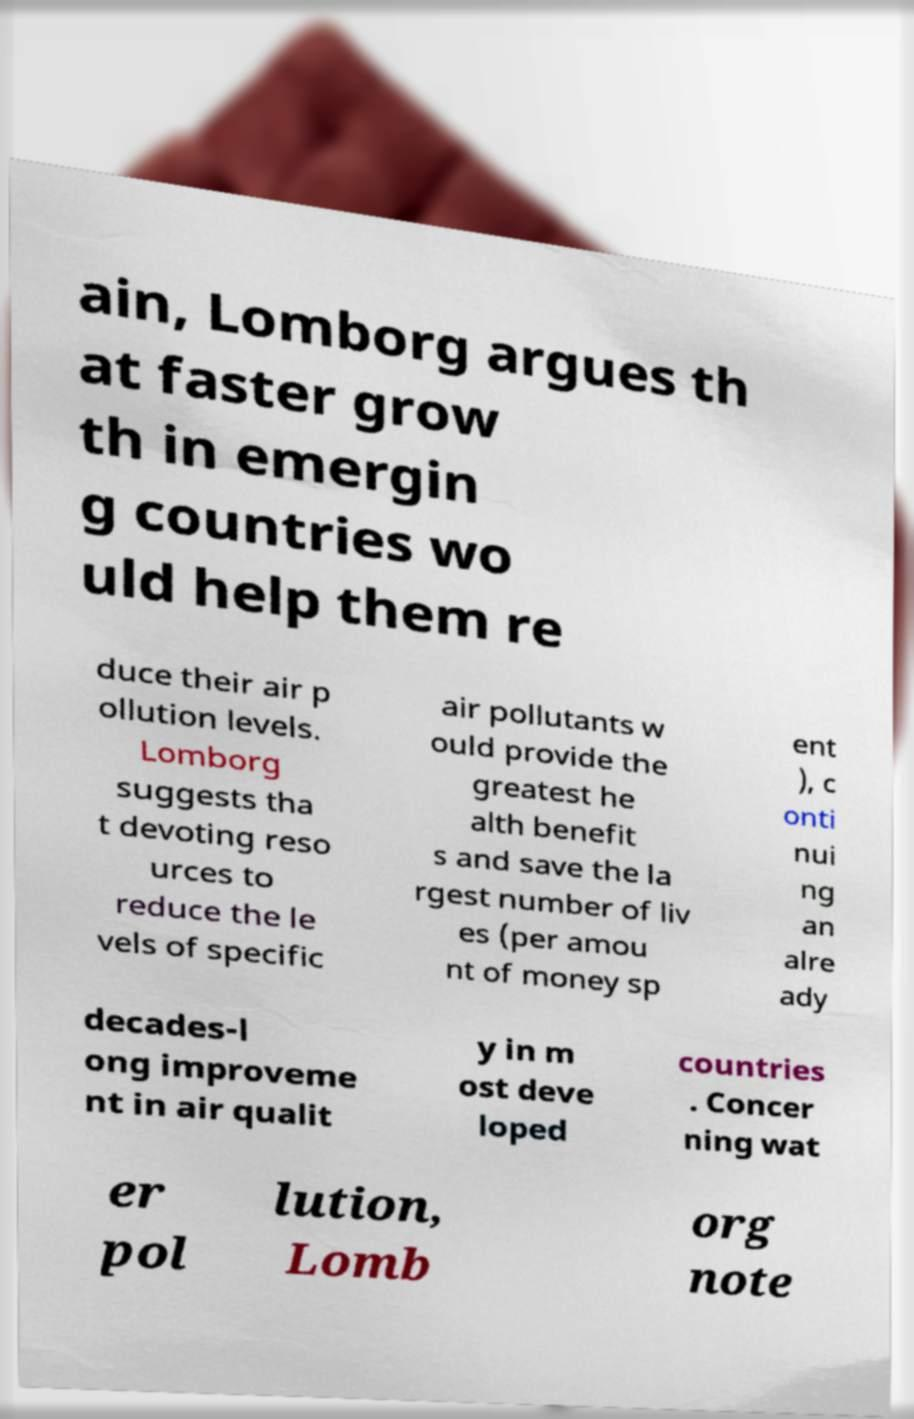For documentation purposes, I need the text within this image transcribed. Could you provide that? ain, Lomborg argues th at faster grow th in emergin g countries wo uld help them re duce their air p ollution levels. Lomborg suggests tha t devoting reso urces to reduce the le vels of specific air pollutants w ould provide the greatest he alth benefit s and save the la rgest number of liv es (per amou nt of money sp ent ), c onti nui ng an alre ady decades-l ong improveme nt in air qualit y in m ost deve loped countries . Concer ning wat er pol lution, Lomb org note 